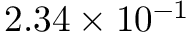Convert formula to latex. <formula><loc_0><loc_0><loc_500><loc_500>2 . 3 4 \times 1 0 ^ { - 1 }</formula> 